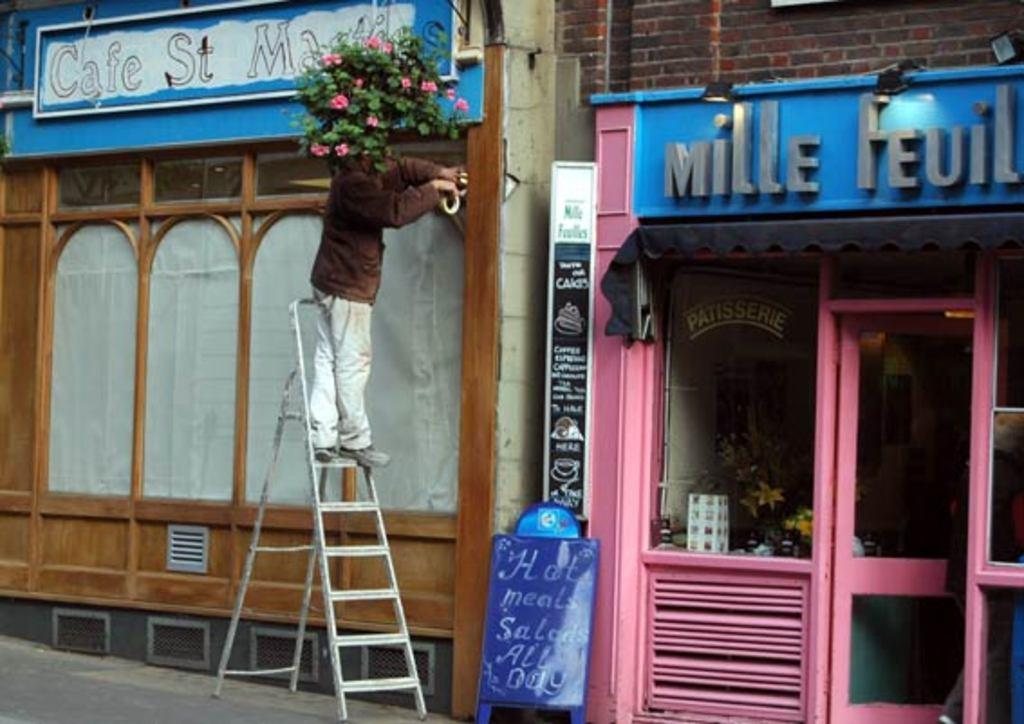<image>
Give a short and clear explanation of the subsequent image. A woman on a ladder beside a pink store called Mille Feuille.. 